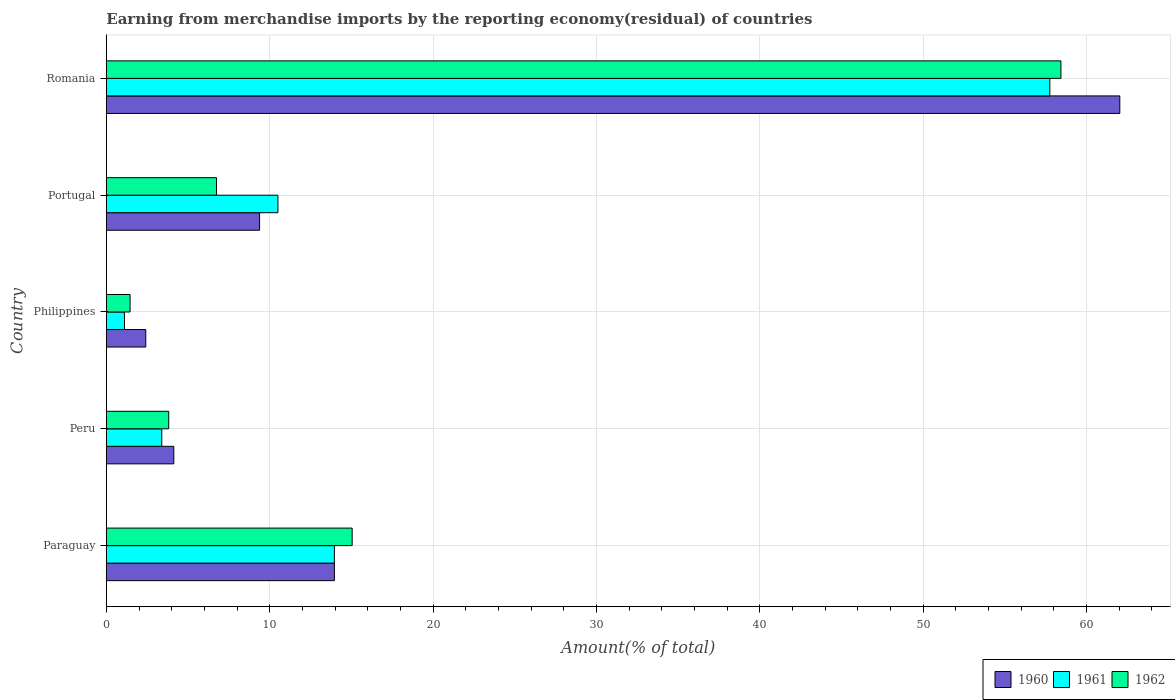How many different coloured bars are there?
Keep it short and to the point. 3. How many groups of bars are there?
Offer a terse response. 5. In how many cases, is the number of bars for a given country not equal to the number of legend labels?
Give a very brief answer. 0. What is the percentage of amount earned from merchandise imports in 1960 in Paraguay?
Provide a short and direct response. 13.96. Across all countries, what is the maximum percentage of amount earned from merchandise imports in 1962?
Ensure brevity in your answer.  58.43. Across all countries, what is the minimum percentage of amount earned from merchandise imports in 1962?
Provide a short and direct response. 1.45. In which country was the percentage of amount earned from merchandise imports in 1962 maximum?
Give a very brief answer. Romania. What is the total percentage of amount earned from merchandise imports in 1962 in the graph?
Make the answer very short. 85.49. What is the difference between the percentage of amount earned from merchandise imports in 1961 in Paraguay and that in Peru?
Your response must be concise. 10.56. What is the difference between the percentage of amount earned from merchandise imports in 1962 in Peru and the percentage of amount earned from merchandise imports in 1960 in Paraguay?
Keep it short and to the point. -10.14. What is the average percentage of amount earned from merchandise imports in 1960 per country?
Provide a succinct answer. 18.38. What is the difference between the percentage of amount earned from merchandise imports in 1961 and percentage of amount earned from merchandise imports in 1962 in Portugal?
Provide a succinct answer. 3.76. In how many countries, is the percentage of amount earned from merchandise imports in 1960 greater than 14 %?
Your answer should be compact. 1. What is the ratio of the percentage of amount earned from merchandise imports in 1962 in Philippines to that in Portugal?
Your answer should be compact. 0.22. What is the difference between the highest and the second highest percentage of amount earned from merchandise imports in 1960?
Offer a terse response. 48.07. What is the difference between the highest and the lowest percentage of amount earned from merchandise imports in 1961?
Provide a succinct answer. 56.64. What does the 1st bar from the bottom in Philippines represents?
Offer a terse response. 1960. Is it the case that in every country, the sum of the percentage of amount earned from merchandise imports in 1960 and percentage of amount earned from merchandise imports in 1961 is greater than the percentage of amount earned from merchandise imports in 1962?
Offer a terse response. Yes. How many bars are there?
Offer a very short reply. 15. Are all the bars in the graph horizontal?
Offer a very short reply. Yes. Does the graph contain any zero values?
Keep it short and to the point. No. Where does the legend appear in the graph?
Provide a short and direct response. Bottom right. How many legend labels are there?
Ensure brevity in your answer.  3. How are the legend labels stacked?
Your response must be concise. Horizontal. What is the title of the graph?
Provide a short and direct response. Earning from merchandise imports by the reporting economy(residual) of countries. Does "2003" appear as one of the legend labels in the graph?
Your answer should be compact. No. What is the label or title of the X-axis?
Offer a very short reply. Amount(% of total). What is the label or title of the Y-axis?
Offer a very short reply. Country. What is the Amount(% of total) in 1960 in Paraguay?
Keep it short and to the point. 13.96. What is the Amount(% of total) of 1961 in Paraguay?
Your answer should be very brief. 13.96. What is the Amount(% of total) in 1962 in Paraguay?
Your answer should be compact. 15.05. What is the Amount(% of total) of 1960 in Peru?
Provide a succinct answer. 4.13. What is the Amount(% of total) of 1961 in Peru?
Give a very brief answer. 3.39. What is the Amount(% of total) of 1962 in Peru?
Offer a very short reply. 3.82. What is the Amount(% of total) in 1960 in Philippines?
Provide a short and direct response. 2.41. What is the Amount(% of total) of 1961 in Philippines?
Offer a terse response. 1.11. What is the Amount(% of total) of 1962 in Philippines?
Keep it short and to the point. 1.45. What is the Amount(% of total) of 1960 in Portugal?
Your answer should be compact. 9.38. What is the Amount(% of total) of 1961 in Portugal?
Provide a short and direct response. 10.5. What is the Amount(% of total) in 1962 in Portugal?
Provide a succinct answer. 6.74. What is the Amount(% of total) in 1960 in Romania?
Your response must be concise. 62.03. What is the Amount(% of total) of 1961 in Romania?
Offer a terse response. 57.75. What is the Amount(% of total) of 1962 in Romania?
Offer a terse response. 58.43. Across all countries, what is the maximum Amount(% of total) of 1960?
Give a very brief answer. 62.03. Across all countries, what is the maximum Amount(% of total) of 1961?
Provide a succinct answer. 57.75. Across all countries, what is the maximum Amount(% of total) in 1962?
Give a very brief answer. 58.43. Across all countries, what is the minimum Amount(% of total) of 1960?
Provide a short and direct response. 2.41. Across all countries, what is the minimum Amount(% of total) in 1961?
Provide a short and direct response. 1.11. Across all countries, what is the minimum Amount(% of total) in 1962?
Provide a succinct answer. 1.45. What is the total Amount(% of total) of 1960 in the graph?
Your answer should be compact. 91.91. What is the total Amount(% of total) of 1961 in the graph?
Offer a very short reply. 86.71. What is the total Amount(% of total) in 1962 in the graph?
Give a very brief answer. 85.49. What is the difference between the Amount(% of total) in 1960 in Paraguay and that in Peru?
Provide a succinct answer. 9.83. What is the difference between the Amount(% of total) in 1961 in Paraguay and that in Peru?
Provide a short and direct response. 10.56. What is the difference between the Amount(% of total) in 1962 in Paraguay and that in Peru?
Ensure brevity in your answer.  11.23. What is the difference between the Amount(% of total) of 1960 in Paraguay and that in Philippines?
Ensure brevity in your answer.  11.55. What is the difference between the Amount(% of total) in 1961 in Paraguay and that in Philippines?
Keep it short and to the point. 12.85. What is the difference between the Amount(% of total) of 1962 in Paraguay and that in Philippines?
Your response must be concise. 13.59. What is the difference between the Amount(% of total) in 1960 in Paraguay and that in Portugal?
Provide a succinct answer. 4.58. What is the difference between the Amount(% of total) in 1961 in Paraguay and that in Portugal?
Your answer should be compact. 3.45. What is the difference between the Amount(% of total) of 1962 in Paraguay and that in Portugal?
Keep it short and to the point. 8.3. What is the difference between the Amount(% of total) of 1960 in Paraguay and that in Romania?
Your answer should be compact. -48.07. What is the difference between the Amount(% of total) of 1961 in Paraguay and that in Romania?
Offer a very short reply. -43.79. What is the difference between the Amount(% of total) of 1962 in Paraguay and that in Romania?
Your answer should be compact. -43.38. What is the difference between the Amount(% of total) in 1960 in Peru and that in Philippines?
Ensure brevity in your answer.  1.71. What is the difference between the Amount(% of total) of 1961 in Peru and that in Philippines?
Offer a very short reply. 2.28. What is the difference between the Amount(% of total) in 1962 in Peru and that in Philippines?
Provide a short and direct response. 2.37. What is the difference between the Amount(% of total) of 1960 in Peru and that in Portugal?
Ensure brevity in your answer.  -5.25. What is the difference between the Amount(% of total) of 1961 in Peru and that in Portugal?
Make the answer very short. -7.11. What is the difference between the Amount(% of total) of 1962 in Peru and that in Portugal?
Your answer should be very brief. -2.92. What is the difference between the Amount(% of total) in 1960 in Peru and that in Romania?
Your response must be concise. -57.9. What is the difference between the Amount(% of total) of 1961 in Peru and that in Romania?
Your answer should be very brief. -54.35. What is the difference between the Amount(% of total) in 1962 in Peru and that in Romania?
Provide a succinct answer. -54.61. What is the difference between the Amount(% of total) in 1960 in Philippines and that in Portugal?
Your response must be concise. -6.96. What is the difference between the Amount(% of total) of 1961 in Philippines and that in Portugal?
Your answer should be very brief. -9.39. What is the difference between the Amount(% of total) in 1962 in Philippines and that in Portugal?
Keep it short and to the point. -5.29. What is the difference between the Amount(% of total) in 1960 in Philippines and that in Romania?
Offer a very short reply. -59.62. What is the difference between the Amount(% of total) in 1961 in Philippines and that in Romania?
Provide a succinct answer. -56.64. What is the difference between the Amount(% of total) in 1962 in Philippines and that in Romania?
Ensure brevity in your answer.  -56.97. What is the difference between the Amount(% of total) in 1960 in Portugal and that in Romania?
Offer a terse response. -52.65. What is the difference between the Amount(% of total) in 1961 in Portugal and that in Romania?
Give a very brief answer. -47.24. What is the difference between the Amount(% of total) in 1962 in Portugal and that in Romania?
Provide a short and direct response. -51.68. What is the difference between the Amount(% of total) in 1960 in Paraguay and the Amount(% of total) in 1961 in Peru?
Provide a succinct answer. 10.57. What is the difference between the Amount(% of total) of 1960 in Paraguay and the Amount(% of total) of 1962 in Peru?
Provide a succinct answer. 10.14. What is the difference between the Amount(% of total) of 1961 in Paraguay and the Amount(% of total) of 1962 in Peru?
Give a very brief answer. 10.14. What is the difference between the Amount(% of total) of 1960 in Paraguay and the Amount(% of total) of 1961 in Philippines?
Provide a succinct answer. 12.85. What is the difference between the Amount(% of total) of 1960 in Paraguay and the Amount(% of total) of 1962 in Philippines?
Ensure brevity in your answer.  12.51. What is the difference between the Amount(% of total) in 1961 in Paraguay and the Amount(% of total) in 1962 in Philippines?
Provide a short and direct response. 12.5. What is the difference between the Amount(% of total) of 1960 in Paraguay and the Amount(% of total) of 1961 in Portugal?
Provide a short and direct response. 3.46. What is the difference between the Amount(% of total) in 1960 in Paraguay and the Amount(% of total) in 1962 in Portugal?
Your response must be concise. 7.22. What is the difference between the Amount(% of total) in 1961 in Paraguay and the Amount(% of total) in 1962 in Portugal?
Your answer should be very brief. 7.21. What is the difference between the Amount(% of total) of 1960 in Paraguay and the Amount(% of total) of 1961 in Romania?
Offer a terse response. -43.79. What is the difference between the Amount(% of total) of 1960 in Paraguay and the Amount(% of total) of 1962 in Romania?
Your answer should be compact. -44.47. What is the difference between the Amount(% of total) in 1961 in Paraguay and the Amount(% of total) in 1962 in Romania?
Your answer should be very brief. -44.47. What is the difference between the Amount(% of total) in 1960 in Peru and the Amount(% of total) in 1961 in Philippines?
Keep it short and to the point. 3.02. What is the difference between the Amount(% of total) of 1960 in Peru and the Amount(% of total) of 1962 in Philippines?
Provide a succinct answer. 2.68. What is the difference between the Amount(% of total) of 1961 in Peru and the Amount(% of total) of 1962 in Philippines?
Your response must be concise. 1.94. What is the difference between the Amount(% of total) in 1960 in Peru and the Amount(% of total) in 1961 in Portugal?
Give a very brief answer. -6.37. What is the difference between the Amount(% of total) of 1960 in Peru and the Amount(% of total) of 1962 in Portugal?
Your answer should be compact. -2.62. What is the difference between the Amount(% of total) of 1961 in Peru and the Amount(% of total) of 1962 in Portugal?
Ensure brevity in your answer.  -3.35. What is the difference between the Amount(% of total) in 1960 in Peru and the Amount(% of total) in 1961 in Romania?
Give a very brief answer. -53.62. What is the difference between the Amount(% of total) in 1960 in Peru and the Amount(% of total) in 1962 in Romania?
Make the answer very short. -54.3. What is the difference between the Amount(% of total) of 1961 in Peru and the Amount(% of total) of 1962 in Romania?
Provide a succinct answer. -55.03. What is the difference between the Amount(% of total) of 1960 in Philippines and the Amount(% of total) of 1961 in Portugal?
Your response must be concise. -8.09. What is the difference between the Amount(% of total) of 1960 in Philippines and the Amount(% of total) of 1962 in Portugal?
Offer a terse response. -4.33. What is the difference between the Amount(% of total) in 1961 in Philippines and the Amount(% of total) in 1962 in Portugal?
Provide a succinct answer. -5.63. What is the difference between the Amount(% of total) of 1960 in Philippines and the Amount(% of total) of 1961 in Romania?
Give a very brief answer. -55.33. What is the difference between the Amount(% of total) in 1960 in Philippines and the Amount(% of total) in 1962 in Romania?
Your answer should be compact. -56.01. What is the difference between the Amount(% of total) of 1961 in Philippines and the Amount(% of total) of 1962 in Romania?
Make the answer very short. -57.32. What is the difference between the Amount(% of total) of 1960 in Portugal and the Amount(% of total) of 1961 in Romania?
Offer a terse response. -48.37. What is the difference between the Amount(% of total) in 1960 in Portugal and the Amount(% of total) in 1962 in Romania?
Ensure brevity in your answer.  -49.05. What is the difference between the Amount(% of total) of 1961 in Portugal and the Amount(% of total) of 1962 in Romania?
Offer a very short reply. -47.92. What is the average Amount(% of total) of 1960 per country?
Give a very brief answer. 18.38. What is the average Amount(% of total) in 1961 per country?
Your response must be concise. 17.34. What is the average Amount(% of total) of 1962 per country?
Your response must be concise. 17.1. What is the difference between the Amount(% of total) of 1960 and Amount(% of total) of 1961 in Paraguay?
Give a very brief answer. 0. What is the difference between the Amount(% of total) of 1960 and Amount(% of total) of 1962 in Paraguay?
Your answer should be compact. -1.09. What is the difference between the Amount(% of total) of 1961 and Amount(% of total) of 1962 in Paraguay?
Offer a terse response. -1.09. What is the difference between the Amount(% of total) of 1960 and Amount(% of total) of 1961 in Peru?
Your answer should be very brief. 0.74. What is the difference between the Amount(% of total) in 1960 and Amount(% of total) in 1962 in Peru?
Ensure brevity in your answer.  0.31. What is the difference between the Amount(% of total) in 1961 and Amount(% of total) in 1962 in Peru?
Your response must be concise. -0.43. What is the difference between the Amount(% of total) of 1960 and Amount(% of total) of 1961 in Philippines?
Provide a succinct answer. 1.3. What is the difference between the Amount(% of total) in 1960 and Amount(% of total) in 1962 in Philippines?
Provide a succinct answer. 0.96. What is the difference between the Amount(% of total) of 1961 and Amount(% of total) of 1962 in Philippines?
Keep it short and to the point. -0.34. What is the difference between the Amount(% of total) in 1960 and Amount(% of total) in 1961 in Portugal?
Your response must be concise. -1.12. What is the difference between the Amount(% of total) of 1960 and Amount(% of total) of 1962 in Portugal?
Your response must be concise. 2.63. What is the difference between the Amount(% of total) in 1961 and Amount(% of total) in 1962 in Portugal?
Give a very brief answer. 3.76. What is the difference between the Amount(% of total) in 1960 and Amount(% of total) in 1961 in Romania?
Make the answer very short. 4.28. What is the difference between the Amount(% of total) of 1960 and Amount(% of total) of 1962 in Romania?
Your response must be concise. 3.6. What is the difference between the Amount(% of total) in 1961 and Amount(% of total) in 1962 in Romania?
Your response must be concise. -0.68. What is the ratio of the Amount(% of total) of 1960 in Paraguay to that in Peru?
Provide a short and direct response. 3.38. What is the ratio of the Amount(% of total) in 1961 in Paraguay to that in Peru?
Provide a succinct answer. 4.11. What is the ratio of the Amount(% of total) in 1962 in Paraguay to that in Peru?
Your response must be concise. 3.94. What is the ratio of the Amount(% of total) of 1960 in Paraguay to that in Philippines?
Provide a short and direct response. 5.78. What is the ratio of the Amount(% of total) in 1961 in Paraguay to that in Philippines?
Your answer should be compact. 12.58. What is the ratio of the Amount(% of total) in 1962 in Paraguay to that in Philippines?
Offer a very short reply. 10.35. What is the ratio of the Amount(% of total) in 1960 in Paraguay to that in Portugal?
Ensure brevity in your answer.  1.49. What is the ratio of the Amount(% of total) of 1961 in Paraguay to that in Portugal?
Ensure brevity in your answer.  1.33. What is the ratio of the Amount(% of total) of 1962 in Paraguay to that in Portugal?
Provide a short and direct response. 2.23. What is the ratio of the Amount(% of total) in 1960 in Paraguay to that in Romania?
Offer a very short reply. 0.23. What is the ratio of the Amount(% of total) in 1961 in Paraguay to that in Romania?
Your answer should be compact. 0.24. What is the ratio of the Amount(% of total) of 1962 in Paraguay to that in Romania?
Give a very brief answer. 0.26. What is the ratio of the Amount(% of total) of 1960 in Peru to that in Philippines?
Make the answer very short. 1.71. What is the ratio of the Amount(% of total) in 1961 in Peru to that in Philippines?
Provide a succinct answer. 3.06. What is the ratio of the Amount(% of total) in 1962 in Peru to that in Philippines?
Offer a very short reply. 2.63. What is the ratio of the Amount(% of total) of 1960 in Peru to that in Portugal?
Offer a terse response. 0.44. What is the ratio of the Amount(% of total) of 1961 in Peru to that in Portugal?
Your answer should be compact. 0.32. What is the ratio of the Amount(% of total) in 1962 in Peru to that in Portugal?
Ensure brevity in your answer.  0.57. What is the ratio of the Amount(% of total) of 1960 in Peru to that in Romania?
Offer a very short reply. 0.07. What is the ratio of the Amount(% of total) of 1961 in Peru to that in Romania?
Provide a short and direct response. 0.06. What is the ratio of the Amount(% of total) of 1962 in Peru to that in Romania?
Make the answer very short. 0.07. What is the ratio of the Amount(% of total) of 1960 in Philippines to that in Portugal?
Your answer should be very brief. 0.26. What is the ratio of the Amount(% of total) of 1961 in Philippines to that in Portugal?
Your answer should be compact. 0.11. What is the ratio of the Amount(% of total) of 1962 in Philippines to that in Portugal?
Offer a terse response. 0.22. What is the ratio of the Amount(% of total) of 1960 in Philippines to that in Romania?
Ensure brevity in your answer.  0.04. What is the ratio of the Amount(% of total) of 1961 in Philippines to that in Romania?
Offer a very short reply. 0.02. What is the ratio of the Amount(% of total) of 1962 in Philippines to that in Romania?
Make the answer very short. 0.02. What is the ratio of the Amount(% of total) in 1960 in Portugal to that in Romania?
Your response must be concise. 0.15. What is the ratio of the Amount(% of total) of 1961 in Portugal to that in Romania?
Provide a short and direct response. 0.18. What is the ratio of the Amount(% of total) in 1962 in Portugal to that in Romania?
Keep it short and to the point. 0.12. What is the difference between the highest and the second highest Amount(% of total) in 1960?
Offer a very short reply. 48.07. What is the difference between the highest and the second highest Amount(% of total) of 1961?
Your answer should be very brief. 43.79. What is the difference between the highest and the second highest Amount(% of total) of 1962?
Your answer should be compact. 43.38. What is the difference between the highest and the lowest Amount(% of total) of 1960?
Keep it short and to the point. 59.62. What is the difference between the highest and the lowest Amount(% of total) in 1961?
Keep it short and to the point. 56.64. What is the difference between the highest and the lowest Amount(% of total) of 1962?
Ensure brevity in your answer.  56.97. 